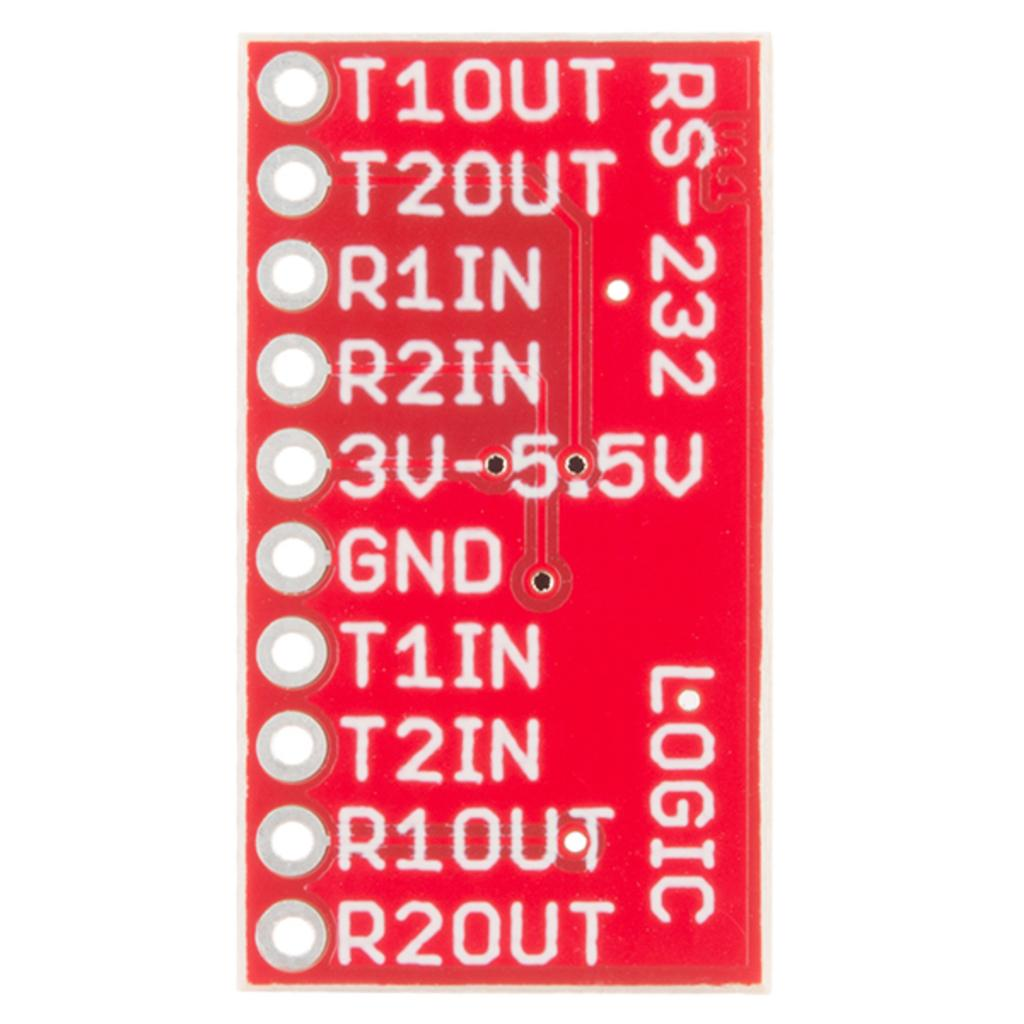<image>
Share a concise interpretation of the image provided. A small red electronic component contains multiple rows of numbers and the word LOGIC near the side. 